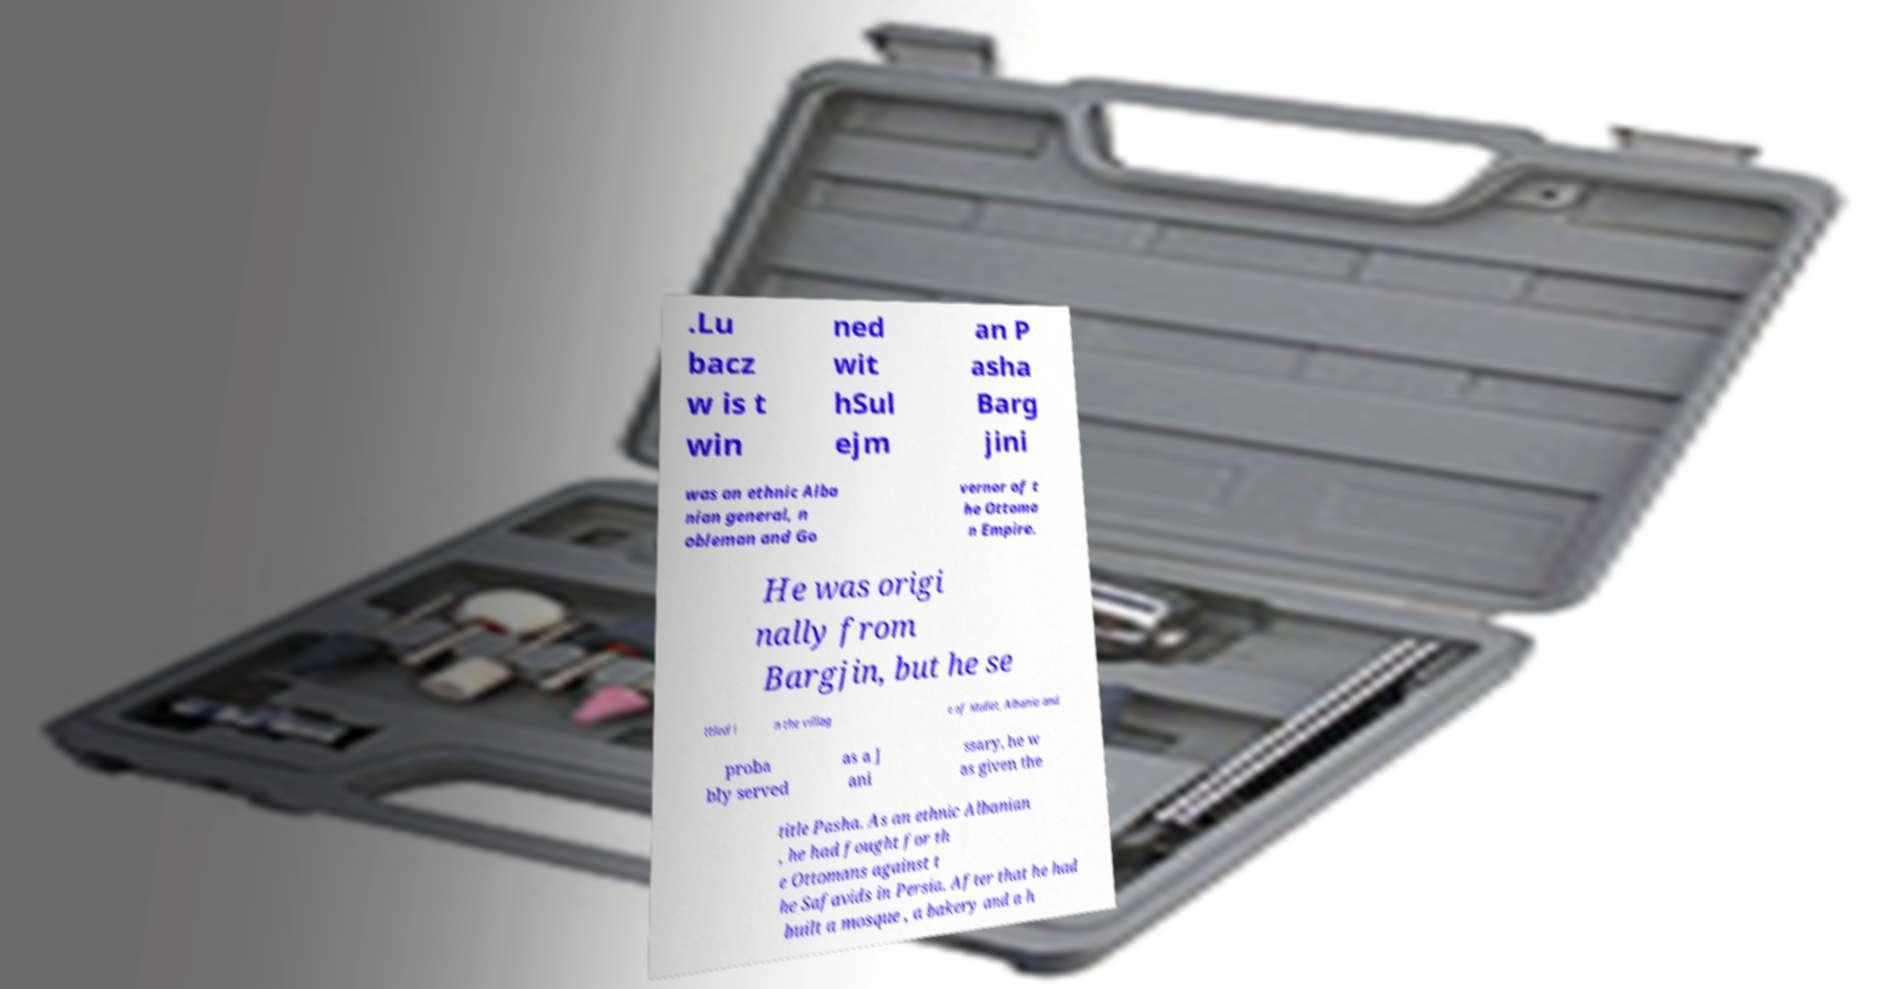Please identify and transcribe the text found in this image. .Lu bacz w is t win ned wit hSul ejm an P asha Barg jini was an ethnic Alba nian general, n obleman and Go vernor of t he Ottoma n Empire. He was origi nally from Bargjin, but he se ttled i n the villag e of Mullet, Albania and proba bly served as a J ani ssary, he w as given the title Pasha. As an ethnic Albanian , he had fought for th e Ottomans against t he Safavids in Persia. After that he had built a mosque , a bakery and a h 